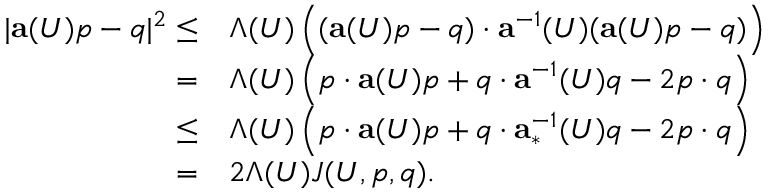<formula> <loc_0><loc_0><loc_500><loc_500>\begin{array} { r l } { | a ( U ) p - q | ^ { 2 } \leq } & { \Lambda ( U ) \left ( ( a ( U ) p - q ) \cdot a ^ { - 1 } ( U ) ( a ( U ) p - q ) \right ) } \\ { = } & { \Lambda ( U ) \left ( p \cdot a ( U ) p + q \cdot a ^ { - 1 } ( U ) q - 2 p \cdot q \right ) } \\ { \leq } & { \Lambda ( U ) \left ( p \cdot a ( U ) p + q \cdot a _ { * } ^ { - 1 } ( U ) q - 2 p \cdot q \right ) } \\ { = } & { 2 \Lambda ( U ) J ( U , p , q ) . } \end{array}</formula> 